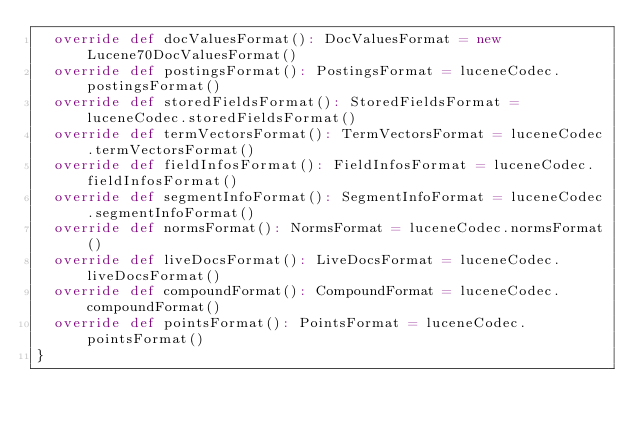<code> <loc_0><loc_0><loc_500><loc_500><_Scala_>  override def docValuesFormat(): DocValuesFormat = new Lucene70DocValuesFormat()
  override def postingsFormat(): PostingsFormat = luceneCodec.postingsFormat()
  override def storedFieldsFormat(): StoredFieldsFormat = luceneCodec.storedFieldsFormat()
  override def termVectorsFormat(): TermVectorsFormat = luceneCodec.termVectorsFormat()
  override def fieldInfosFormat(): FieldInfosFormat = luceneCodec.fieldInfosFormat()
  override def segmentInfoFormat(): SegmentInfoFormat = luceneCodec.segmentInfoFormat()
  override def normsFormat(): NormsFormat = luceneCodec.normsFormat()
  override def liveDocsFormat(): LiveDocsFormat = luceneCodec.liveDocsFormat()
  override def compoundFormat(): CompoundFormat = luceneCodec.compoundFormat()
  override def pointsFormat(): PointsFormat = luceneCodec.pointsFormat()
}
</code> 